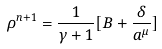<formula> <loc_0><loc_0><loc_500><loc_500>\rho ^ { n + 1 } = \frac { 1 } { \gamma + 1 } [ B + \frac { \delta } { a ^ { \mu } } ]</formula> 